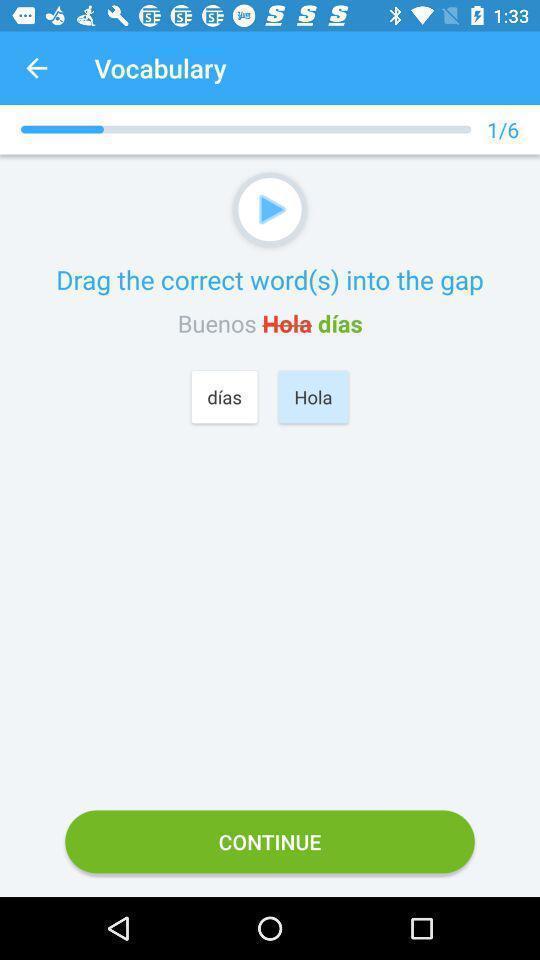Explain the elements present in this screenshot. Screen displaying vocabulary page of a language learning app. 